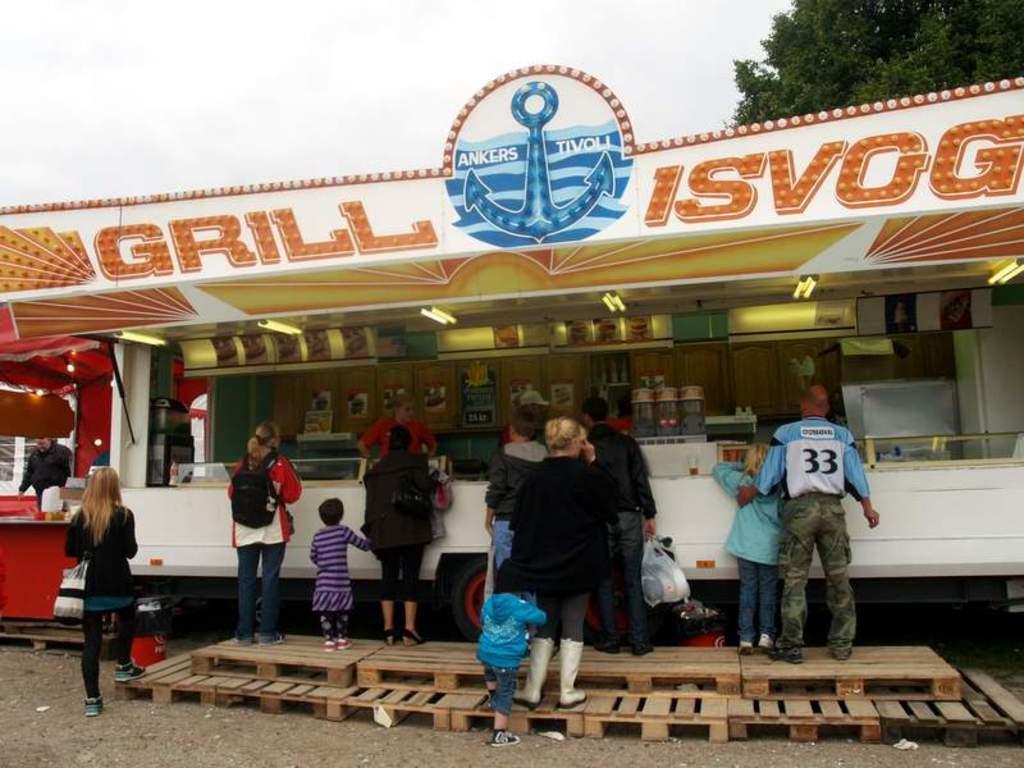In one or two sentences, can you explain what this image depicts? In this image we can see a food truck with a name board and a logo on it. We can also see some containers, food, ceiling lights and some people standing inside the truck. On the bottom of the image we can see a group of people standing on the wooden stage. In that a person is holding a cover. We can also see some cylinders beside it. On the backside we can see a tree and the sky which looks cloudy. 